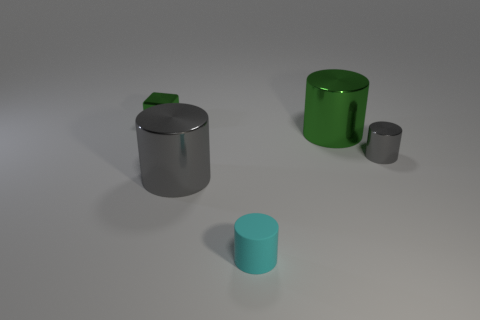What number of other objects are the same color as the small cube?
Offer a very short reply. 1. Does the small metal cylinder have the same color as the large object that is to the left of the big green shiny cylinder?
Provide a succinct answer. Yes. What number of big metallic cylinders have the same color as the tiny metal cylinder?
Your response must be concise. 1. Are there fewer small cyan metallic cubes than green cylinders?
Make the answer very short. Yes. What color is the metal object behind the big metallic object that is on the right side of the rubber cylinder?
Offer a very short reply. Green. What is the material of the tiny green block that is to the left of the gray shiny object that is right of the big metallic cylinder to the left of the matte cylinder?
Your answer should be compact. Metal. There is a gray thing that is on the left side of the cyan thing; is it the same size as the big green shiny thing?
Ensure brevity in your answer.  Yes. What is the large gray cylinder right of the tiny block made of?
Your answer should be very brief. Metal. Is the number of gray things greater than the number of cyan cylinders?
Offer a very short reply. Yes. How many objects are either large metallic objects behind the tiny gray metallic cylinder or large green things?
Offer a very short reply. 1. 